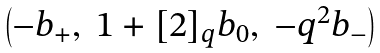<formula> <loc_0><loc_0><loc_500><loc_500>\begin{pmatrix} - b _ { + } , \ 1 + [ 2 ] _ { q } b _ { 0 } , \ - q ^ { 2 } b _ { - } \end{pmatrix}</formula> 